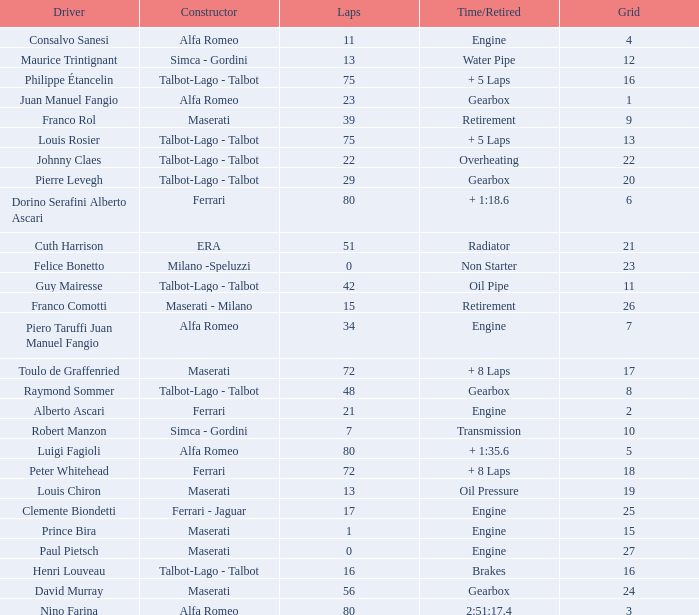What was the smallest grid for Prince bira? 15.0. Give me the full table as a dictionary. {'header': ['Driver', 'Constructor', 'Laps', 'Time/Retired', 'Grid'], 'rows': [['Consalvo Sanesi', 'Alfa Romeo', '11', 'Engine', '4'], ['Maurice Trintignant', 'Simca - Gordini', '13', 'Water Pipe', '12'], ['Philippe Étancelin', 'Talbot-Lago - Talbot', '75', '+ 5 Laps', '16'], ['Juan Manuel Fangio', 'Alfa Romeo', '23', 'Gearbox', '1'], ['Franco Rol', 'Maserati', '39', 'Retirement', '9'], ['Louis Rosier', 'Talbot-Lago - Talbot', '75', '+ 5 Laps', '13'], ['Johnny Claes', 'Talbot-Lago - Talbot', '22', 'Overheating', '22'], ['Pierre Levegh', 'Talbot-Lago - Talbot', '29', 'Gearbox', '20'], ['Dorino Serafini Alberto Ascari', 'Ferrari', '80', '+ 1:18.6', '6'], ['Cuth Harrison', 'ERA', '51', 'Radiator', '21'], ['Felice Bonetto', 'Milano -Speluzzi', '0', 'Non Starter', '23'], ['Guy Mairesse', 'Talbot-Lago - Talbot', '42', 'Oil Pipe', '11'], ['Franco Comotti', 'Maserati - Milano', '15', 'Retirement', '26'], ['Piero Taruffi Juan Manuel Fangio', 'Alfa Romeo', '34', 'Engine', '7'], ['Toulo de Graffenried', 'Maserati', '72', '+ 8 Laps', '17'], ['Raymond Sommer', 'Talbot-Lago - Talbot', '48', 'Gearbox', '8'], ['Alberto Ascari', 'Ferrari', '21', 'Engine', '2'], ['Robert Manzon', 'Simca - Gordini', '7', 'Transmission', '10'], ['Luigi Fagioli', 'Alfa Romeo', '80', '+ 1:35.6', '5'], ['Peter Whitehead', 'Ferrari', '72', '+ 8 Laps', '18'], ['Louis Chiron', 'Maserati', '13', 'Oil Pressure', '19'], ['Clemente Biondetti', 'Ferrari - Jaguar', '17', 'Engine', '25'], ['Prince Bira', 'Maserati', '1', 'Engine', '15'], ['Paul Pietsch', 'Maserati', '0', 'Engine', '27'], ['Henri Louveau', 'Talbot-Lago - Talbot', '16', 'Brakes', '16'], ['David Murray', 'Maserati', '56', 'Gearbox', '24'], ['Nino Farina', 'Alfa Romeo', '80', '2:51:17.4', '3']]} 